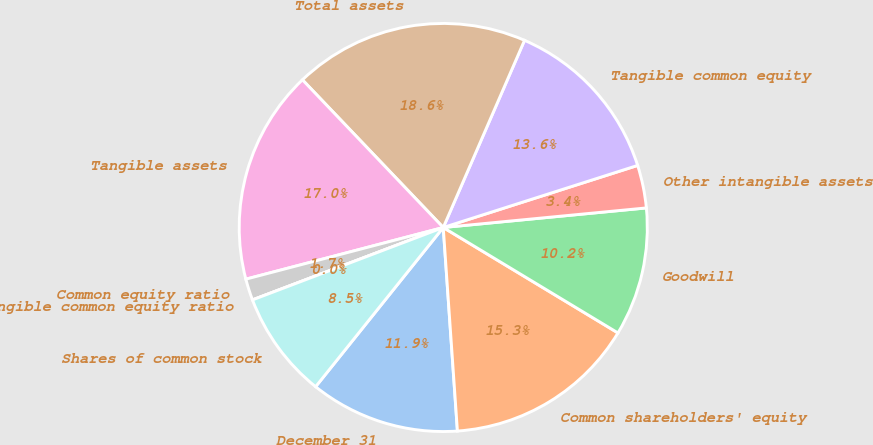Convert chart. <chart><loc_0><loc_0><loc_500><loc_500><pie_chart><fcel>December 31<fcel>Common shareholders' equity<fcel>Goodwill<fcel>Other intangible assets<fcel>Tangible common equity<fcel>Total assets<fcel>Tangible assets<fcel>Common equity ratio<fcel>Tangible common equity ratio<fcel>Shares of common stock<nl><fcel>11.86%<fcel>15.25%<fcel>10.17%<fcel>3.39%<fcel>13.56%<fcel>18.64%<fcel>16.95%<fcel>1.7%<fcel>0.0%<fcel>8.47%<nl></chart> 